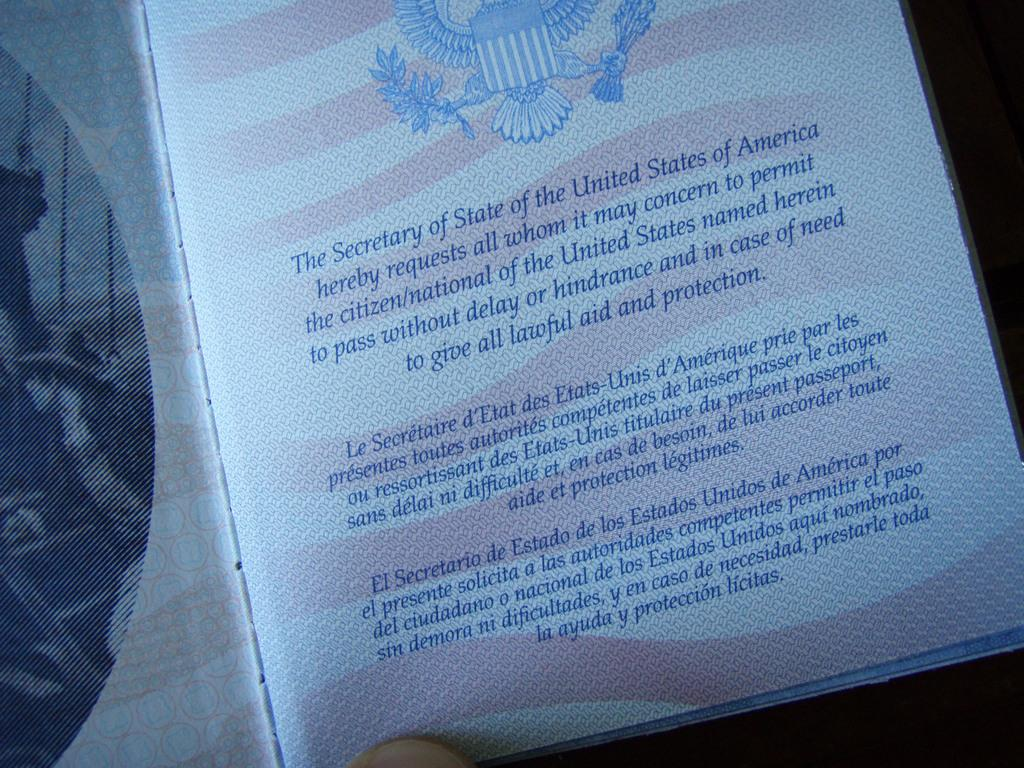<image>
Share a concise interpretation of the image provided. A page with an American pattern and text about a secretary of state. 